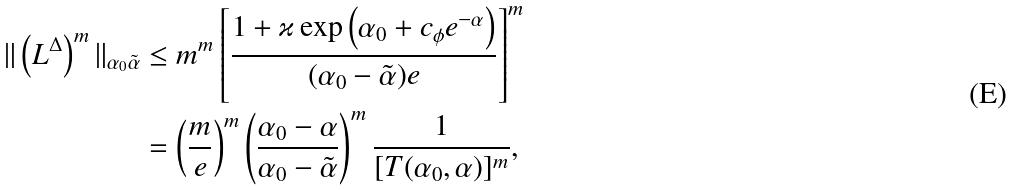<formula> <loc_0><loc_0><loc_500><loc_500>\| \left ( L ^ { \Delta } \right ) ^ { m } \| _ { \alpha _ { 0 } \tilde { \alpha } } & \leq m ^ { m } \left [ \frac { 1 + \varkappa \exp \left ( \alpha _ { 0 } + c _ { \phi } e ^ { - \alpha } \right ) } { ( \alpha _ { 0 } - \tilde { \alpha } ) e } \right ] ^ { m } \\ & = \left ( \frac { m } { e } \right ) ^ { m } \left ( \frac { \alpha _ { 0 } - \alpha } { \alpha _ { 0 } - \tilde { \alpha } } \right ) ^ { m } \frac { 1 } { [ T ( \alpha _ { 0 } , \alpha ) ] ^ { m } } ,</formula> 